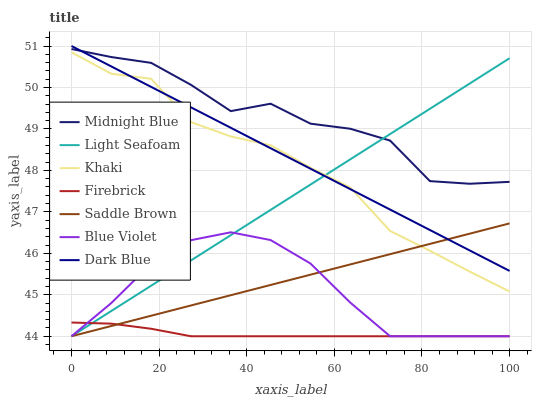Does Firebrick have the minimum area under the curve?
Answer yes or no. Yes. Does Midnight Blue have the maximum area under the curve?
Answer yes or no. Yes. Does Midnight Blue have the minimum area under the curve?
Answer yes or no. No. Does Firebrick have the maximum area under the curve?
Answer yes or no. No. Is Saddle Brown the smoothest?
Answer yes or no. Yes. Is Midnight Blue the roughest?
Answer yes or no. Yes. Is Firebrick the smoothest?
Answer yes or no. No. Is Firebrick the roughest?
Answer yes or no. No. Does Firebrick have the lowest value?
Answer yes or no. Yes. Does Midnight Blue have the lowest value?
Answer yes or no. No. Does Dark Blue have the highest value?
Answer yes or no. Yes. Does Midnight Blue have the highest value?
Answer yes or no. No. Is Blue Violet less than Dark Blue?
Answer yes or no. Yes. Is Khaki greater than Firebrick?
Answer yes or no. Yes. Does Dark Blue intersect Midnight Blue?
Answer yes or no. Yes. Is Dark Blue less than Midnight Blue?
Answer yes or no. No. Is Dark Blue greater than Midnight Blue?
Answer yes or no. No. Does Blue Violet intersect Dark Blue?
Answer yes or no. No. 